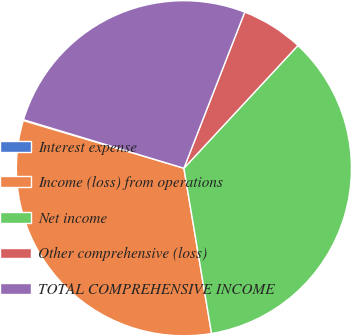Convert chart to OTSL. <chart><loc_0><loc_0><loc_500><loc_500><pie_chart><fcel>Interest expense<fcel>Income (loss) from operations<fcel>Net income<fcel>Other comprehensive (loss)<fcel>TOTAL COMPREHENSIVE INCOME<nl><fcel>0.09%<fcel>32.23%<fcel>35.45%<fcel>6.0%<fcel>26.24%<nl></chart> 